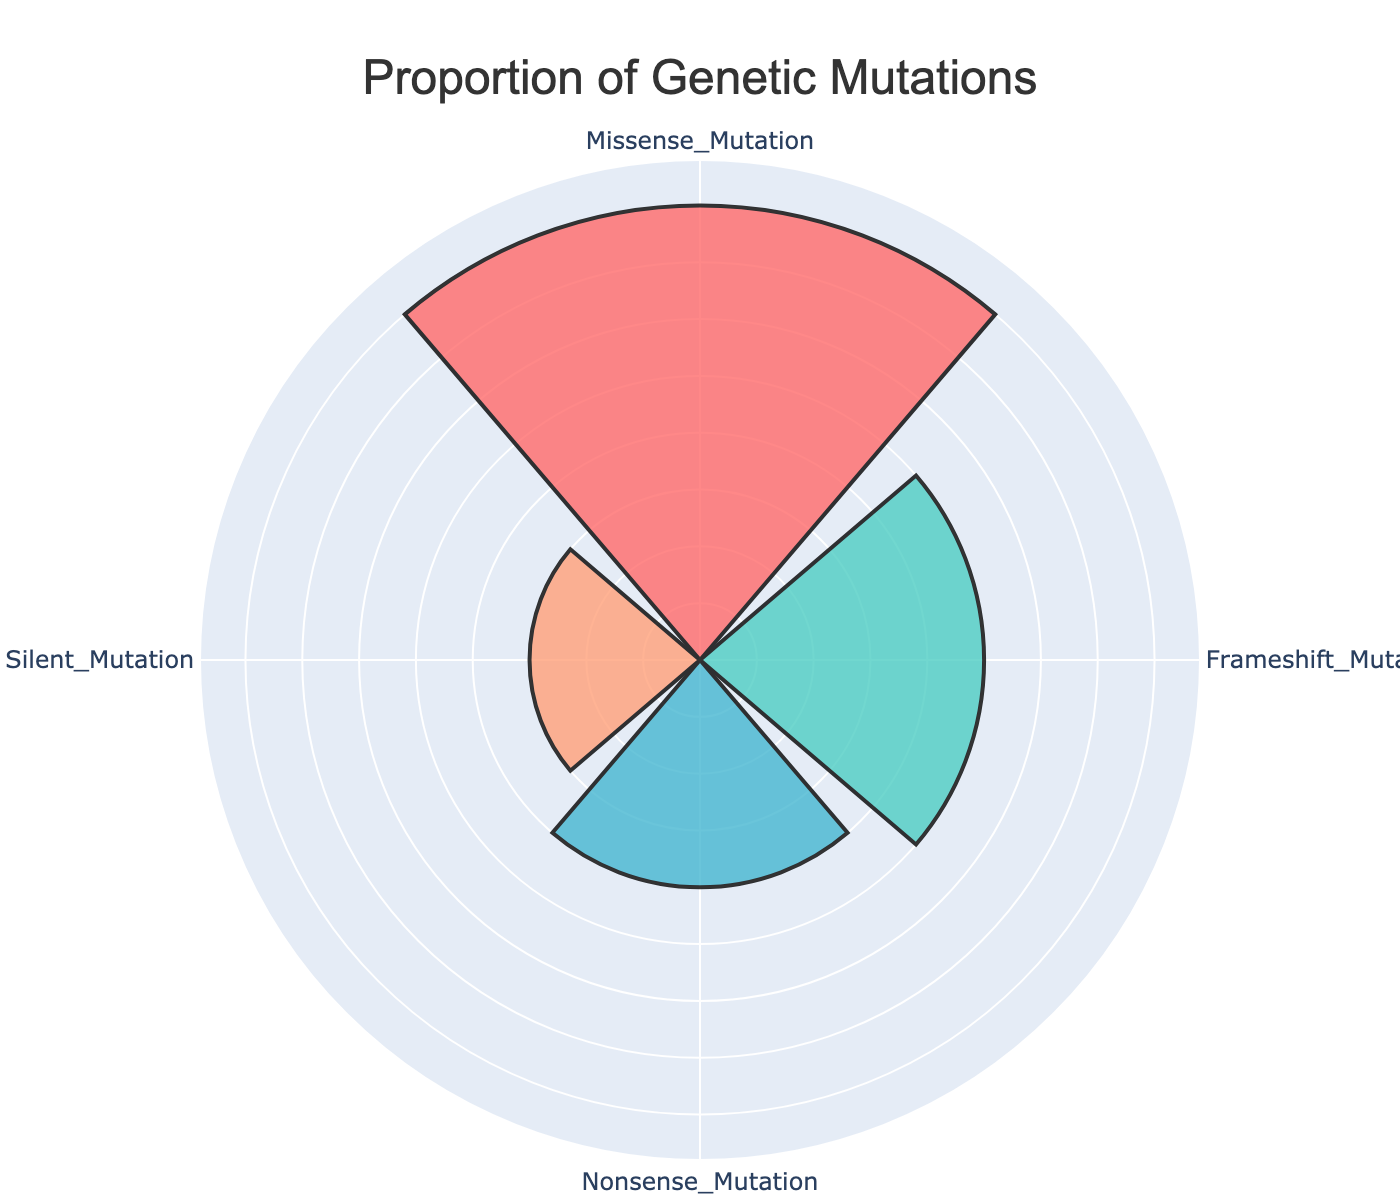What is the title of the figure? The title is written at the top of the figure. It says "Proportion of Genetic Mutations".
Answer: Proportion of Genetic Mutations What is the proportion of Missense Mutations observed in the study population? The value for Missense Mutation is directly visible on the radial bar for that category, which is 40%.
Answer: 40% Which type of genetic mutation has the lowest proportion in the study? By comparing the proportions, the Silent Mutation has the lowest value of 15%.
Answer: Silent Mutation How many types of genetic mutations are displayed in the figure? By counting the distinct categories shown in the figure, there are four types of genetic mutations.
Answer: 4 What’s the total proportion of Frameshift and Nonsense Mutations together? Add the proportions of Frameshift Mutation (25%) and Nonsense Mutation (20%) together: 25% + 20% = 45%.
Answer: 45% What is the difference in proportion between Missense Mutations and Silent Mutations? Subtract the proportion of Silent Mutation (15%) from Missense Mutation (40%): 40% - 15% = 25%.
Answer: 25% Which mutation type has a greater proportion, Frameshift or Nonsense? Compare the proportions: Frameshift Mutation has 25% and Nonsense Mutation has 20%, so Frameshift Mutation has a greater proportion.
Answer: Frameshift Mutation If you were to select the top two types of mutations by their proportions, which ones would they be? The top two types can be identified by ranking the proportions: 1) Missense Mutation (40%), 2) Frameshift Mutation (25%).
Answer: Missense Mutation and Frameshift Mutation How does the proportion of Nonsense Mutations compare to that of Silent Mutations? Nonsense Mutation has a proportion of 20%, while Silent Mutation has 15%. Thus, Nonsense Mutation has a higher proportion.
Answer: Nonsense Mutation What is the average proportion of all four genetic mutation types? Sum the proportions of all four types and divide by 4: (40% + 25% + 20% + 15%) / 4 = 25%.
Answer: 25% 